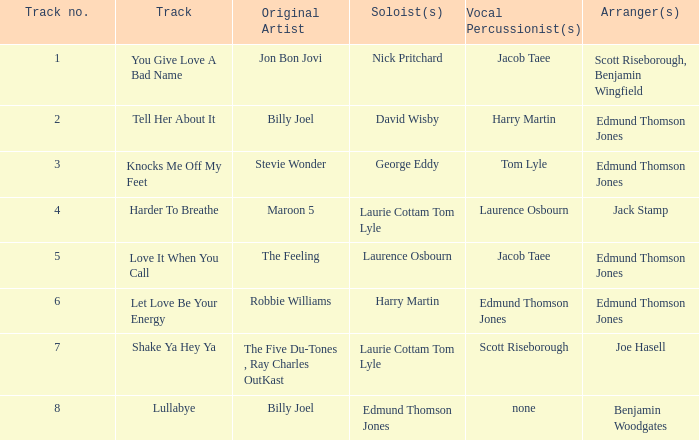Who were the original artist(s) when jack stamp arranged? Maroon 5. 